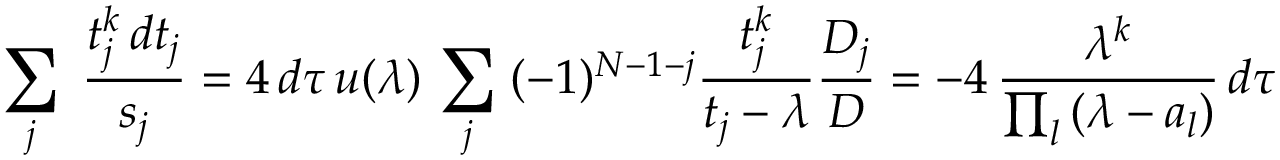Convert formula to latex. <formula><loc_0><loc_0><loc_500><loc_500>\sum _ { j } \, { \frac { t _ { j } ^ { k } \, d t _ { j } } { s _ { j } } } = 4 \, d \tau \, u ( \lambda ) \, \sum _ { j } \, ( - 1 ) ^ { N - 1 - j } { \frac { t _ { j } ^ { k } } { t _ { j } - \lambda } } { \frac { D _ { j } } { D } } = - 4 \, { \frac { \lambda ^ { k } } { \prod _ { l } \, ( \lambda - a _ { l } ) } } \, d \tau</formula> 